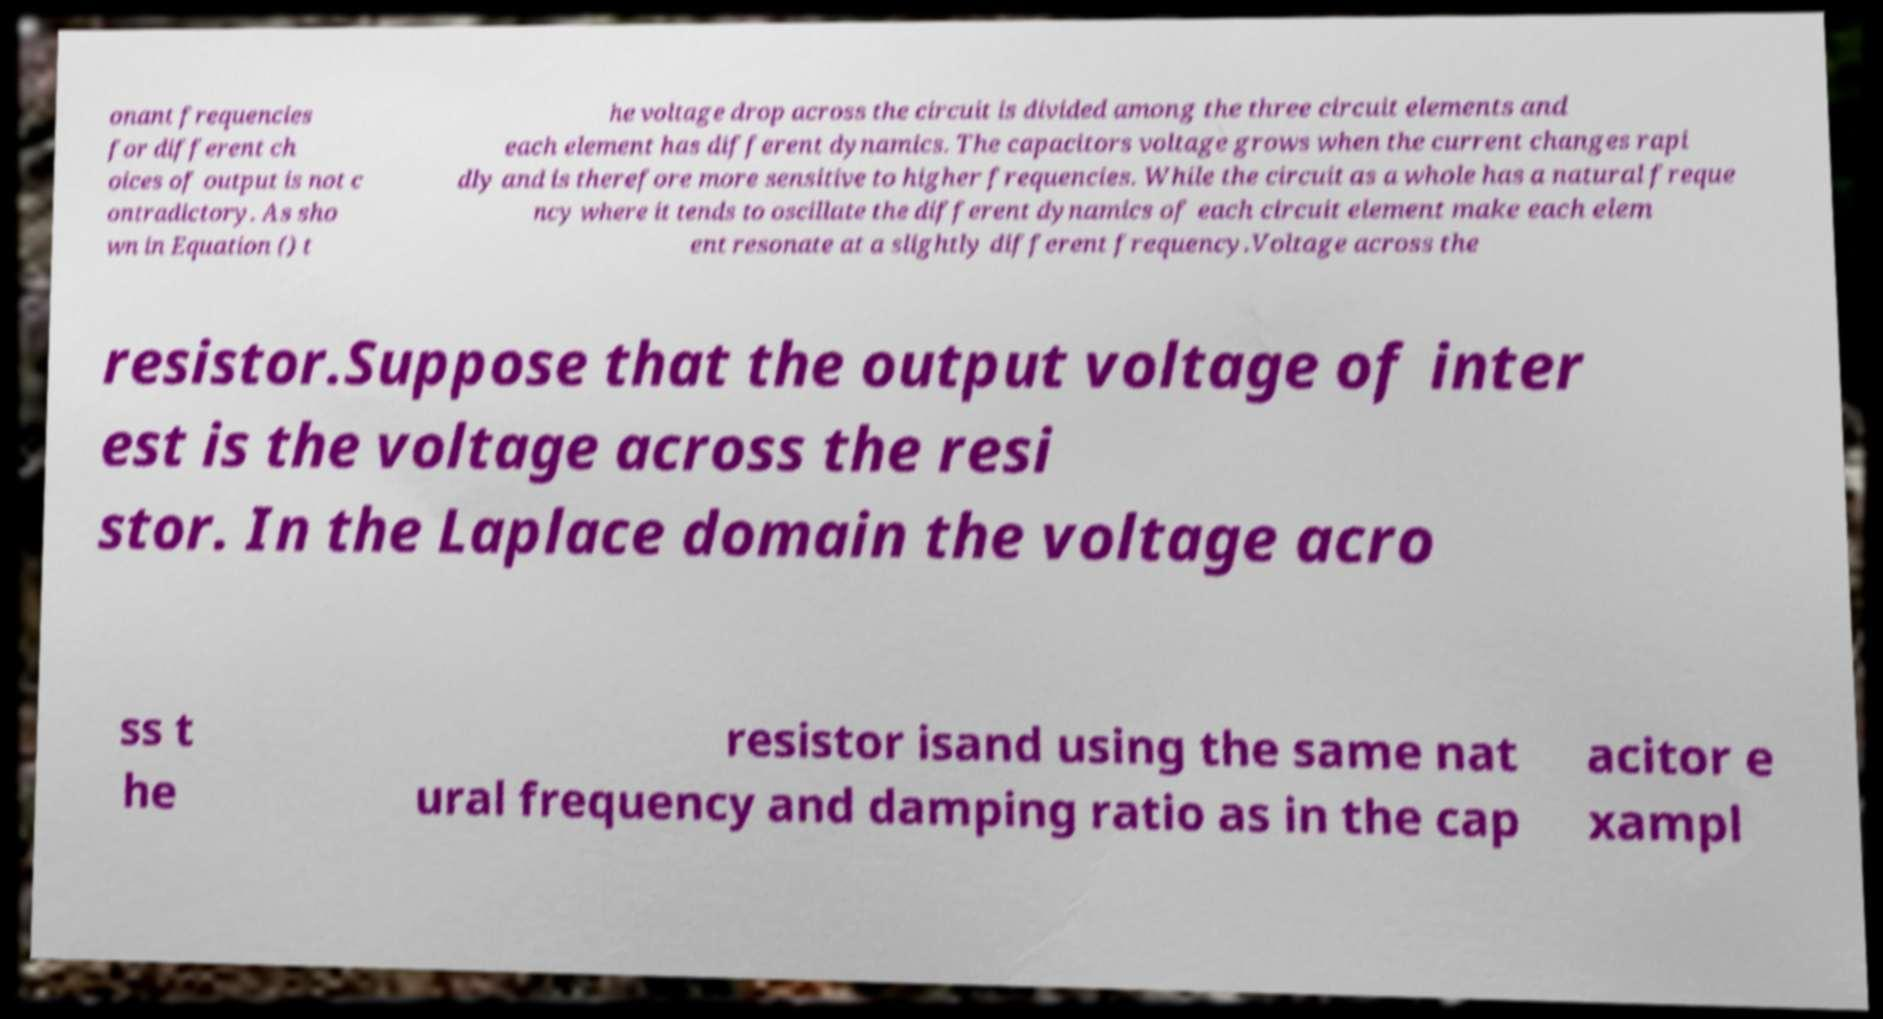What messages or text are displayed in this image? I need them in a readable, typed format. onant frequencies for different ch oices of output is not c ontradictory. As sho wn in Equation () t he voltage drop across the circuit is divided among the three circuit elements and each element has different dynamics. The capacitors voltage grows when the current changes rapi dly and is therefore more sensitive to higher frequencies. While the circuit as a whole has a natural freque ncy where it tends to oscillate the different dynamics of each circuit element make each elem ent resonate at a slightly different frequency.Voltage across the resistor.Suppose that the output voltage of inter est is the voltage across the resi stor. In the Laplace domain the voltage acro ss t he resistor isand using the same nat ural frequency and damping ratio as in the cap acitor e xampl 